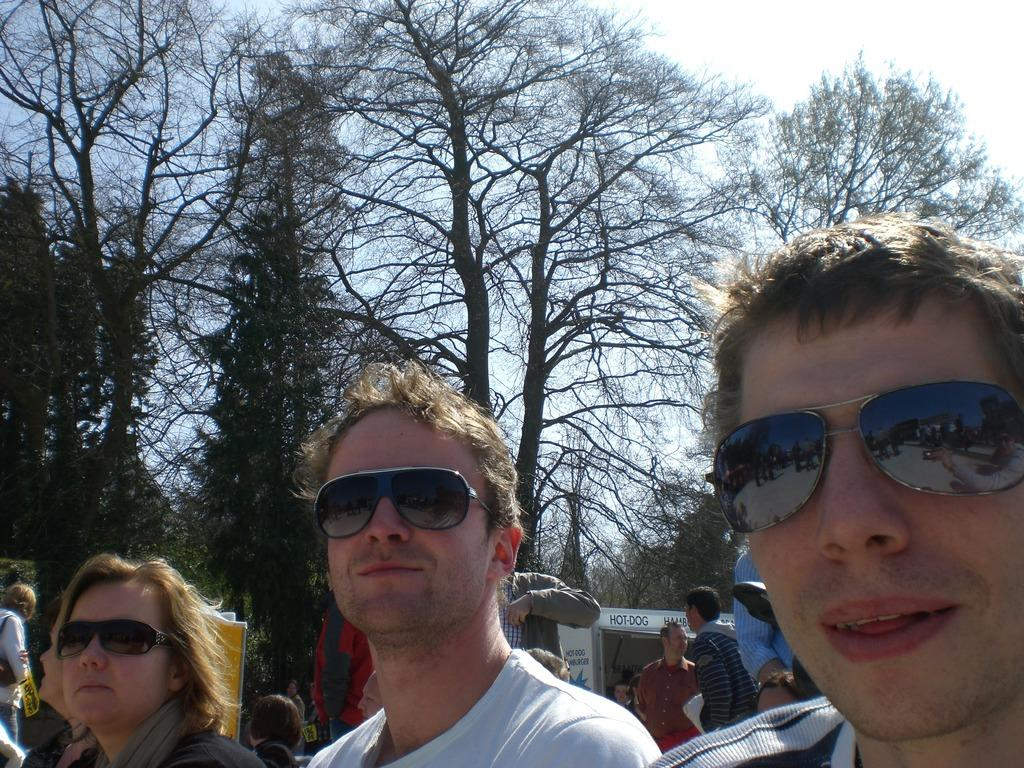How many people are in the image? There are three persons in the image. What are the three persons wearing? The three persons are wearing goggles. Can you describe the background of the image? There are other persons and trees in the background of the image. What is the tax rate for the development project in the image? There is no information about a development project or tax rate in the image. 